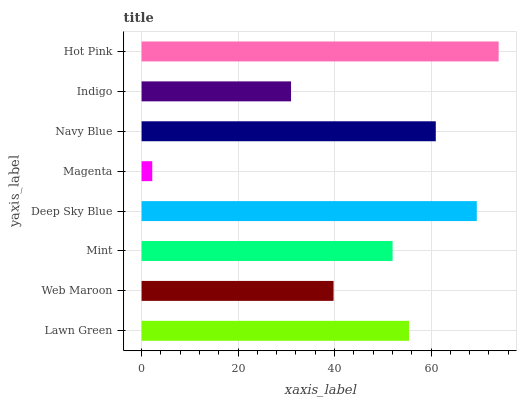Is Magenta the minimum?
Answer yes or no. Yes. Is Hot Pink the maximum?
Answer yes or no. Yes. Is Web Maroon the minimum?
Answer yes or no. No. Is Web Maroon the maximum?
Answer yes or no. No. Is Lawn Green greater than Web Maroon?
Answer yes or no. Yes. Is Web Maroon less than Lawn Green?
Answer yes or no. Yes. Is Web Maroon greater than Lawn Green?
Answer yes or no. No. Is Lawn Green less than Web Maroon?
Answer yes or no. No. Is Lawn Green the high median?
Answer yes or no. Yes. Is Mint the low median?
Answer yes or no. Yes. Is Magenta the high median?
Answer yes or no. No. Is Web Maroon the low median?
Answer yes or no. No. 